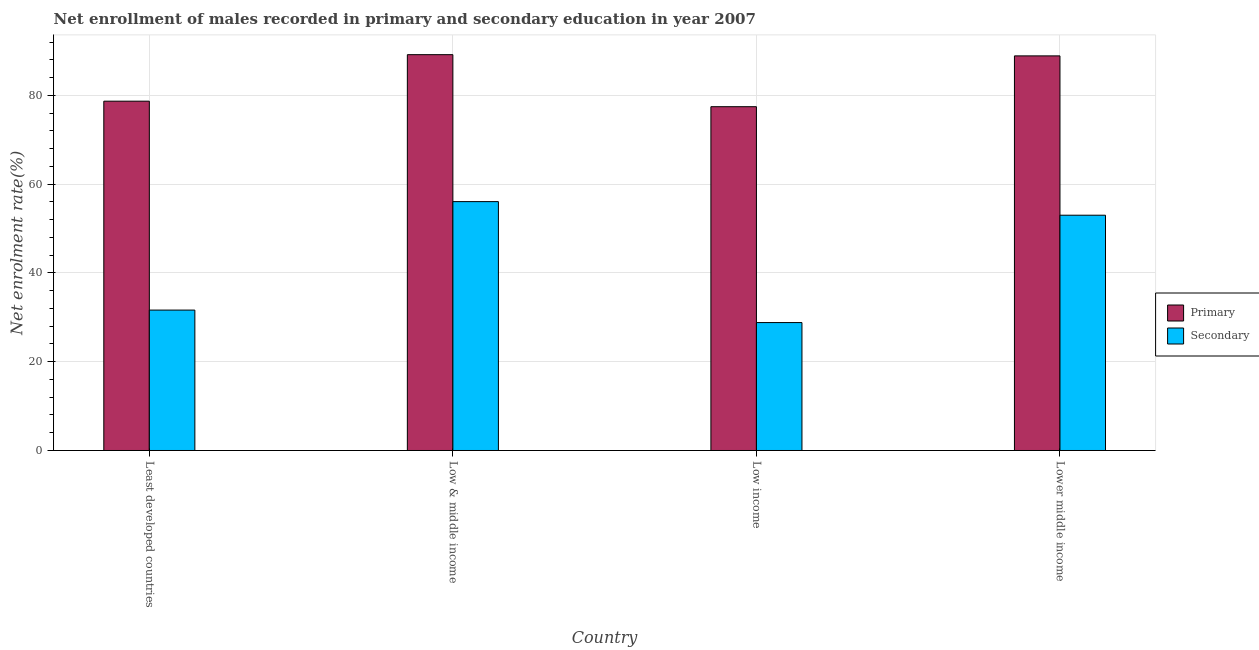Are the number of bars per tick equal to the number of legend labels?
Your answer should be very brief. Yes. How many bars are there on the 4th tick from the right?
Your response must be concise. 2. What is the label of the 2nd group of bars from the left?
Ensure brevity in your answer.  Low & middle income. In how many cases, is the number of bars for a given country not equal to the number of legend labels?
Keep it short and to the point. 0. What is the enrollment rate in primary education in Least developed countries?
Your answer should be very brief. 78.7. Across all countries, what is the maximum enrollment rate in primary education?
Your answer should be very brief. 89.18. Across all countries, what is the minimum enrollment rate in secondary education?
Give a very brief answer. 28.82. In which country was the enrollment rate in primary education maximum?
Make the answer very short. Low & middle income. In which country was the enrollment rate in secondary education minimum?
Provide a succinct answer. Low income. What is the total enrollment rate in secondary education in the graph?
Give a very brief answer. 169.53. What is the difference between the enrollment rate in primary education in Low & middle income and that in Lower middle income?
Provide a short and direct response. 0.28. What is the difference between the enrollment rate in primary education in Low & middle income and the enrollment rate in secondary education in Least developed countries?
Your answer should be compact. 57.55. What is the average enrollment rate in secondary education per country?
Provide a short and direct response. 42.38. What is the difference between the enrollment rate in primary education and enrollment rate in secondary education in Least developed countries?
Provide a short and direct response. 47.07. In how many countries, is the enrollment rate in secondary education greater than 4 %?
Offer a very short reply. 4. What is the ratio of the enrollment rate in primary education in Low income to that in Lower middle income?
Make the answer very short. 0.87. Is the enrollment rate in secondary education in Low income less than that in Lower middle income?
Ensure brevity in your answer.  Yes. Is the difference between the enrollment rate in primary education in Least developed countries and Lower middle income greater than the difference between the enrollment rate in secondary education in Least developed countries and Lower middle income?
Give a very brief answer. Yes. What is the difference between the highest and the second highest enrollment rate in secondary education?
Your answer should be very brief. 3.06. What is the difference between the highest and the lowest enrollment rate in primary education?
Offer a very short reply. 11.72. Is the sum of the enrollment rate in secondary education in Low & middle income and Lower middle income greater than the maximum enrollment rate in primary education across all countries?
Your response must be concise. Yes. What does the 1st bar from the left in Low & middle income represents?
Make the answer very short. Primary. What does the 2nd bar from the right in Low income represents?
Keep it short and to the point. Primary. Are all the bars in the graph horizontal?
Your answer should be very brief. No. What is the difference between two consecutive major ticks on the Y-axis?
Your answer should be very brief. 20. Does the graph contain any zero values?
Provide a succinct answer. No. Does the graph contain grids?
Offer a very short reply. Yes. Where does the legend appear in the graph?
Your response must be concise. Center right. How many legend labels are there?
Give a very brief answer. 2. How are the legend labels stacked?
Offer a terse response. Vertical. What is the title of the graph?
Offer a terse response. Net enrollment of males recorded in primary and secondary education in year 2007. Does "Old" appear as one of the legend labels in the graph?
Your response must be concise. No. What is the label or title of the Y-axis?
Your response must be concise. Net enrolment rate(%). What is the Net enrolment rate(%) in Primary in Least developed countries?
Your answer should be very brief. 78.7. What is the Net enrolment rate(%) of Secondary in Least developed countries?
Provide a short and direct response. 31.63. What is the Net enrolment rate(%) in Primary in Low & middle income?
Your answer should be compact. 89.18. What is the Net enrolment rate(%) of Secondary in Low & middle income?
Provide a succinct answer. 56.07. What is the Net enrolment rate(%) of Primary in Low income?
Provide a short and direct response. 77.46. What is the Net enrolment rate(%) in Secondary in Low income?
Give a very brief answer. 28.82. What is the Net enrolment rate(%) of Primary in Lower middle income?
Keep it short and to the point. 88.9. What is the Net enrolment rate(%) in Secondary in Lower middle income?
Your answer should be very brief. 53.01. Across all countries, what is the maximum Net enrolment rate(%) in Primary?
Provide a short and direct response. 89.18. Across all countries, what is the maximum Net enrolment rate(%) of Secondary?
Keep it short and to the point. 56.07. Across all countries, what is the minimum Net enrolment rate(%) of Primary?
Provide a short and direct response. 77.46. Across all countries, what is the minimum Net enrolment rate(%) of Secondary?
Provide a succinct answer. 28.82. What is the total Net enrolment rate(%) of Primary in the graph?
Your response must be concise. 334.24. What is the total Net enrolment rate(%) in Secondary in the graph?
Provide a short and direct response. 169.53. What is the difference between the Net enrolment rate(%) of Primary in Least developed countries and that in Low & middle income?
Offer a terse response. -10.48. What is the difference between the Net enrolment rate(%) of Secondary in Least developed countries and that in Low & middle income?
Provide a short and direct response. -24.44. What is the difference between the Net enrolment rate(%) in Primary in Least developed countries and that in Low income?
Your answer should be compact. 1.24. What is the difference between the Net enrolment rate(%) in Secondary in Least developed countries and that in Low income?
Provide a short and direct response. 2.81. What is the difference between the Net enrolment rate(%) in Primary in Least developed countries and that in Lower middle income?
Give a very brief answer. -10.21. What is the difference between the Net enrolment rate(%) of Secondary in Least developed countries and that in Lower middle income?
Offer a terse response. -21.38. What is the difference between the Net enrolment rate(%) in Primary in Low & middle income and that in Low income?
Give a very brief answer. 11.72. What is the difference between the Net enrolment rate(%) in Secondary in Low & middle income and that in Low income?
Your response must be concise. 27.25. What is the difference between the Net enrolment rate(%) of Primary in Low & middle income and that in Lower middle income?
Ensure brevity in your answer.  0.28. What is the difference between the Net enrolment rate(%) of Secondary in Low & middle income and that in Lower middle income?
Give a very brief answer. 3.06. What is the difference between the Net enrolment rate(%) in Primary in Low income and that in Lower middle income?
Make the answer very short. -11.45. What is the difference between the Net enrolment rate(%) in Secondary in Low income and that in Lower middle income?
Make the answer very short. -24.19. What is the difference between the Net enrolment rate(%) in Primary in Least developed countries and the Net enrolment rate(%) in Secondary in Low & middle income?
Provide a succinct answer. 22.63. What is the difference between the Net enrolment rate(%) of Primary in Least developed countries and the Net enrolment rate(%) of Secondary in Low income?
Make the answer very short. 49.88. What is the difference between the Net enrolment rate(%) of Primary in Least developed countries and the Net enrolment rate(%) of Secondary in Lower middle income?
Provide a succinct answer. 25.69. What is the difference between the Net enrolment rate(%) of Primary in Low & middle income and the Net enrolment rate(%) of Secondary in Low income?
Give a very brief answer. 60.36. What is the difference between the Net enrolment rate(%) of Primary in Low & middle income and the Net enrolment rate(%) of Secondary in Lower middle income?
Offer a very short reply. 36.17. What is the difference between the Net enrolment rate(%) in Primary in Low income and the Net enrolment rate(%) in Secondary in Lower middle income?
Provide a succinct answer. 24.45. What is the average Net enrolment rate(%) in Primary per country?
Offer a terse response. 83.56. What is the average Net enrolment rate(%) of Secondary per country?
Keep it short and to the point. 42.38. What is the difference between the Net enrolment rate(%) of Primary and Net enrolment rate(%) of Secondary in Least developed countries?
Keep it short and to the point. 47.07. What is the difference between the Net enrolment rate(%) of Primary and Net enrolment rate(%) of Secondary in Low & middle income?
Make the answer very short. 33.11. What is the difference between the Net enrolment rate(%) in Primary and Net enrolment rate(%) in Secondary in Low income?
Offer a very short reply. 48.63. What is the difference between the Net enrolment rate(%) of Primary and Net enrolment rate(%) of Secondary in Lower middle income?
Offer a terse response. 35.9. What is the ratio of the Net enrolment rate(%) of Primary in Least developed countries to that in Low & middle income?
Provide a short and direct response. 0.88. What is the ratio of the Net enrolment rate(%) of Secondary in Least developed countries to that in Low & middle income?
Your answer should be very brief. 0.56. What is the ratio of the Net enrolment rate(%) of Primary in Least developed countries to that in Low income?
Offer a very short reply. 1.02. What is the ratio of the Net enrolment rate(%) in Secondary in Least developed countries to that in Low income?
Ensure brevity in your answer.  1.1. What is the ratio of the Net enrolment rate(%) of Primary in Least developed countries to that in Lower middle income?
Ensure brevity in your answer.  0.89. What is the ratio of the Net enrolment rate(%) of Secondary in Least developed countries to that in Lower middle income?
Give a very brief answer. 0.6. What is the ratio of the Net enrolment rate(%) of Primary in Low & middle income to that in Low income?
Make the answer very short. 1.15. What is the ratio of the Net enrolment rate(%) of Secondary in Low & middle income to that in Low income?
Make the answer very short. 1.95. What is the ratio of the Net enrolment rate(%) in Secondary in Low & middle income to that in Lower middle income?
Provide a succinct answer. 1.06. What is the ratio of the Net enrolment rate(%) in Primary in Low income to that in Lower middle income?
Give a very brief answer. 0.87. What is the ratio of the Net enrolment rate(%) of Secondary in Low income to that in Lower middle income?
Keep it short and to the point. 0.54. What is the difference between the highest and the second highest Net enrolment rate(%) of Primary?
Your answer should be compact. 0.28. What is the difference between the highest and the second highest Net enrolment rate(%) in Secondary?
Give a very brief answer. 3.06. What is the difference between the highest and the lowest Net enrolment rate(%) in Primary?
Give a very brief answer. 11.72. What is the difference between the highest and the lowest Net enrolment rate(%) in Secondary?
Keep it short and to the point. 27.25. 